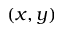<formula> <loc_0><loc_0><loc_500><loc_500>( x , y )</formula> 